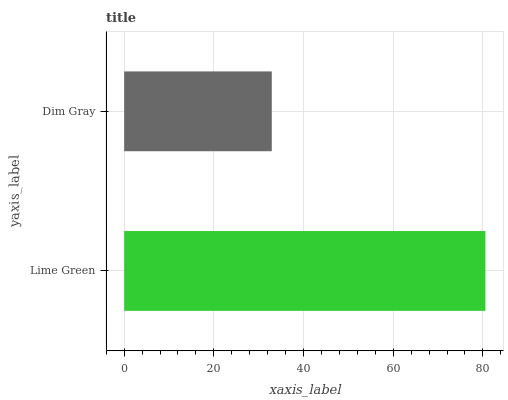Is Dim Gray the minimum?
Answer yes or no. Yes. Is Lime Green the maximum?
Answer yes or no. Yes. Is Dim Gray the maximum?
Answer yes or no. No. Is Lime Green greater than Dim Gray?
Answer yes or no. Yes. Is Dim Gray less than Lime Green?
Answer yes or no. Yes. Is Dim Gray greater than Lime Green?
Answer yes or no. No. Is Lime Green less than Dim Gray?
Answer yes or no. No. Is Lime Green the high median?
Answer yes or no. Yes. Is Dim Gray the low median?
Answer yes or no. Yes. Is Dim Gray the high median?
Answer yes or no. No. Is Lime Green the low median?
Answer yes or no. No. 